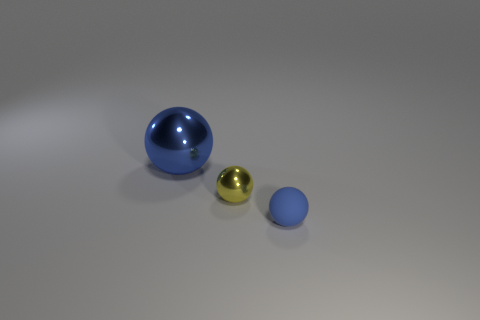Subtract all big blue shiny balls. How many balls are left? 2 Subtract all yellow balls. How many balls are left? 2 Subtract 3 spheres. How many spheres are left? 0 Add 3 red cylinders. How many objects exist? 6 Subtract all cyan cylinders. How many blue balls are left? 2 Subtract all tiny red metallic spheres. Subtract all tiny blue matte things. How many objects are left? 2 Add 2 big blue things. How many big blue things are left? 3 Add 3 small red spheres. How many small red spheres exist? 3 Subtract 0 gray cubes. How many objects are left? 3 Subtract all brown balls. Subtract all brown cylinders. How many balls are left? 3 